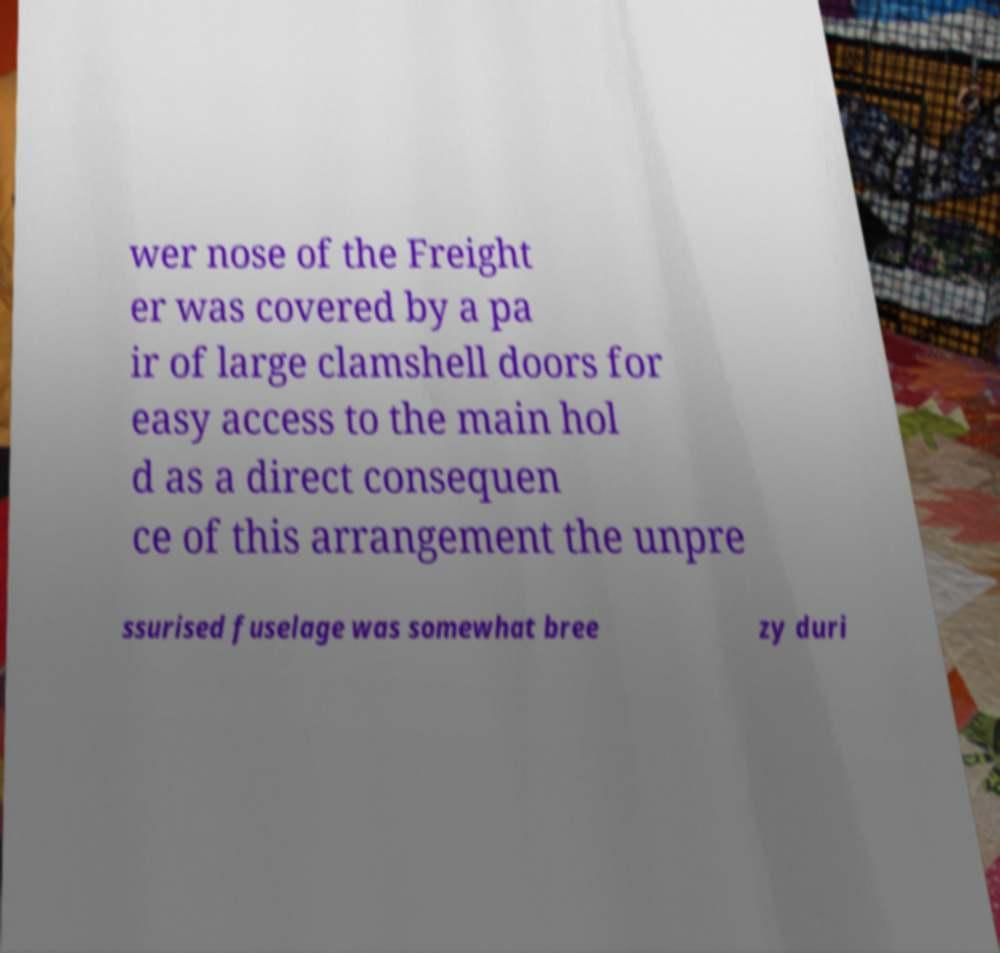Please identify and transcribe the text found in this image. wer nose of the Freight er was covered by a pa ir of large clamshell doors for easy access to the main hol d as a direct consequen ce of this arrangement the unpre ssurised fuselage was somewhat bree zy duri 